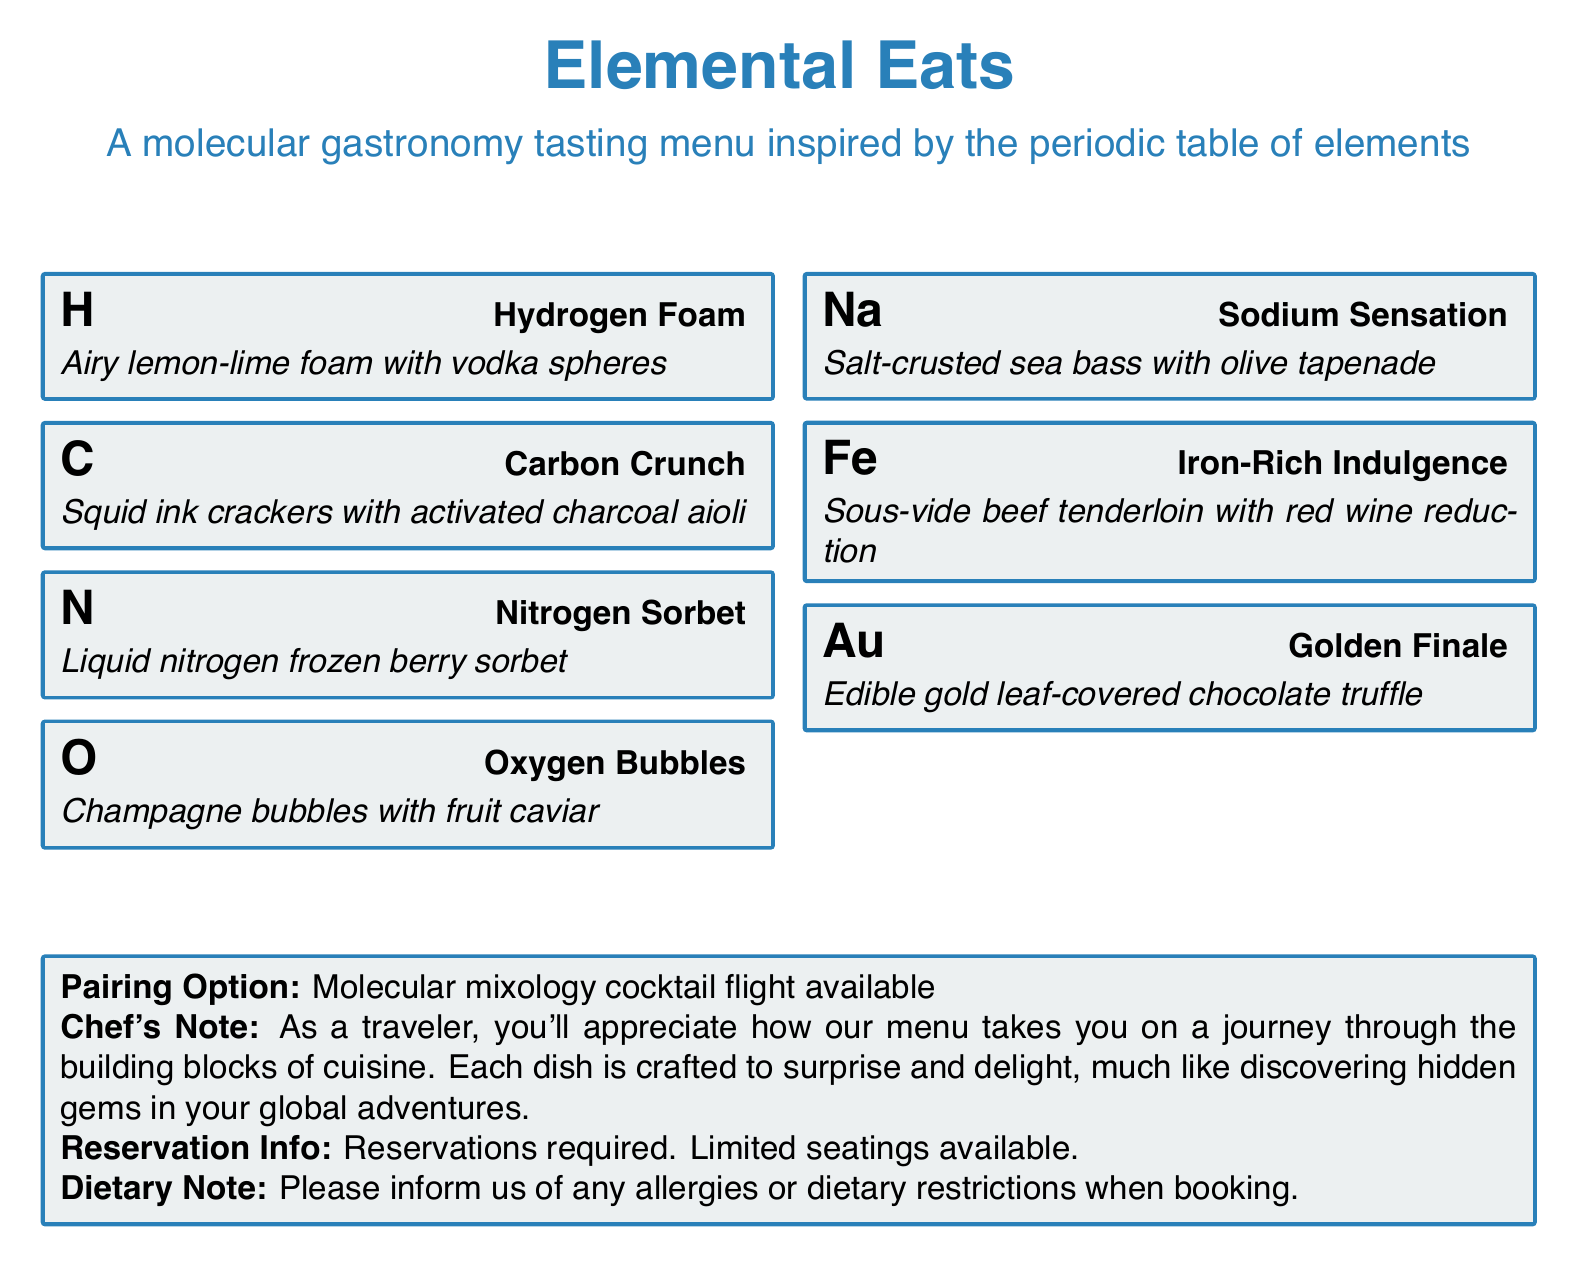What is the name of the menu? The name of the menu is stated at the top of the document.
Answer: Elemental Eats What type of cuisine does the tasting menu represent? The description in the document mentions the style of cooking for the menu.
Answer: Molecular gastronomy How many courses are listed in the menu? The document provides a list of the courses representing each dish.
Answer: Seven What is the pairing option available? The document specifies an additional option that complements the menu.
Answer: Molecular mixology cocktail flight Which course is represented by the symbol "Au"? The chemical symbol in the menu corresponds to a specific dish.
Answer: Edible gold leaf-covered chocolate truffle What is the dietary note for reservations? The document includes a note advising guests about dietary needs.
Answer: Allergies or dietary restrictions What is the main ingredient in the "Fe" course? The menu item includes the main component of the dish.
Answer: Beef tenderloin What color is used for the course boxes? The document describes the background color of the boxes used for the menu items.
Answer: Element gray 